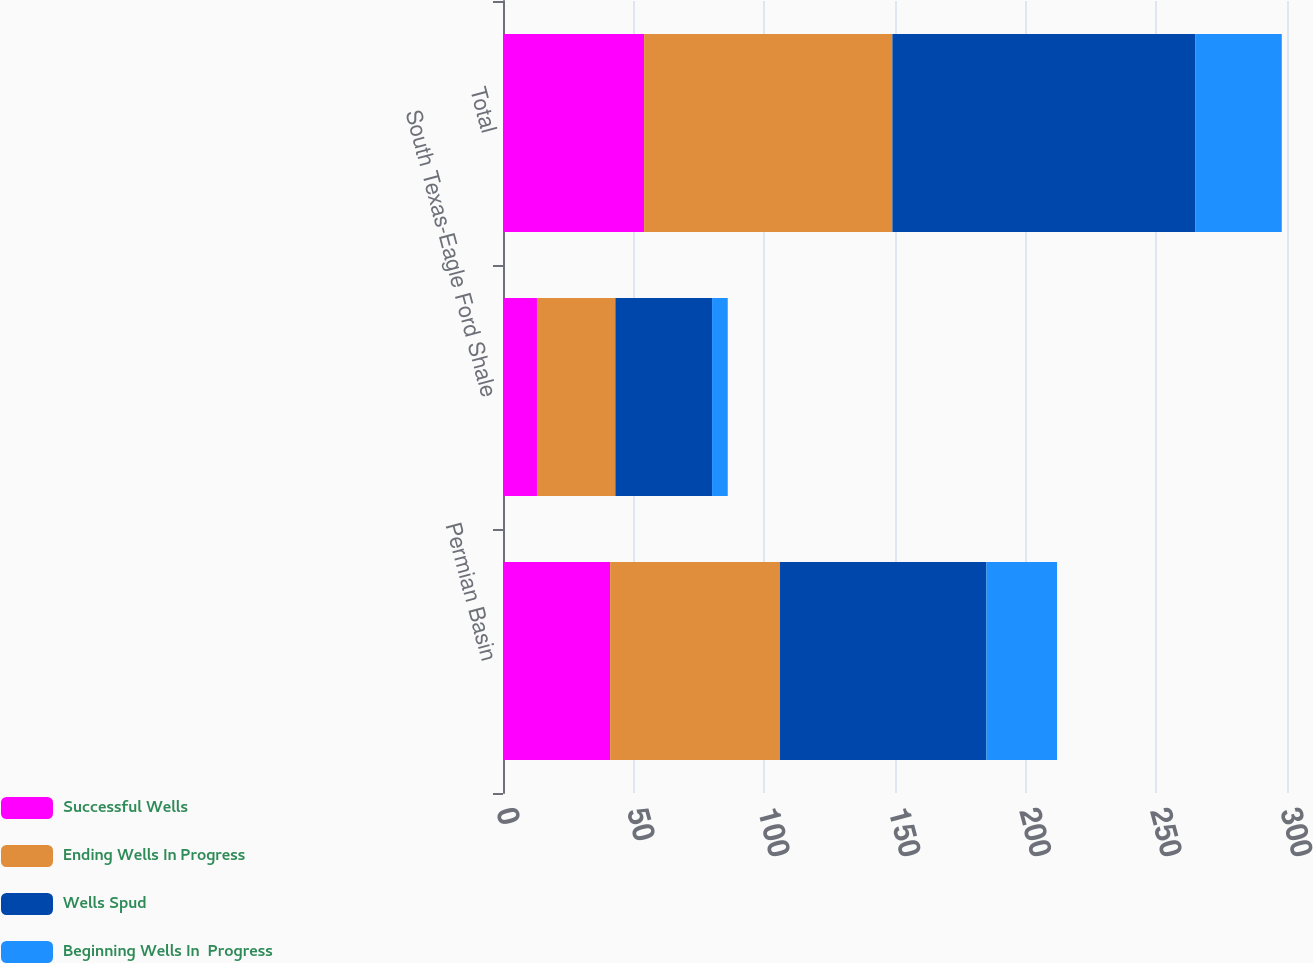Convert chart to OTSL. <chart><loc_0><loc_0><loc_500><loc_500><stacked_bar_chart><ecel><fcel>Permian Basin<fcel>South Texas-Eagle Ford Shale<fcel>Total<nl><fcel>Successful Wells<fcel>41<fcel>13<fcel>54<nl><fcel>Ending Wells In Progress<fcel>65<fcel>30<fcel>95<nl><fcel>Wells Spud<fcel>79<fcel>37<fcel>116<nl><fcel>Beginning Wells In  Progress<fcel>27<fcel>6<fcel>33<nl></chart> 